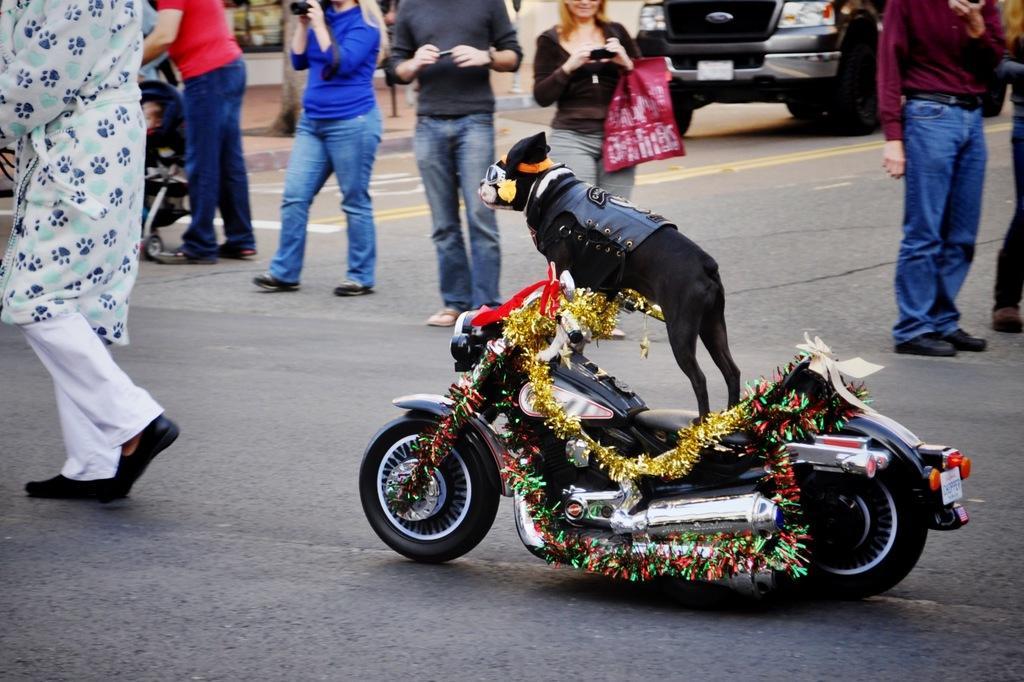Could you give a brief overview of what you see in this image? The picture is on the middle of a road. In the middle a dog is riding a decorated bike. The dog is wearing dress,hat,and sunglasses. Around it there are many persons. Some people are clicking photo. In the background there are vehicle, stroller. 